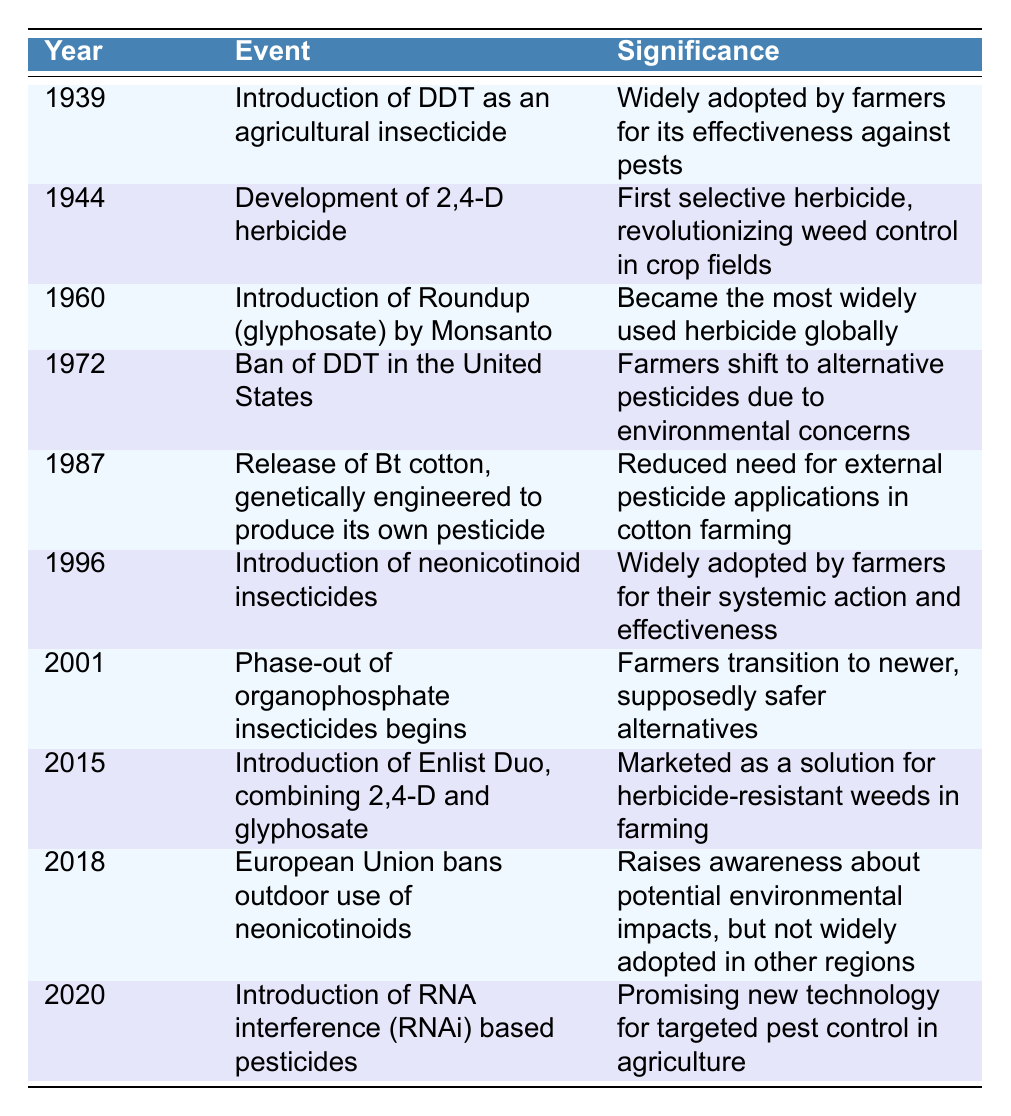What year was DDT introduced as an agricultural insecticide? The table clearly shows that DDT was introduced in the year 1939.
Answer: 1939 What was the significance of the development of 2,4-D herbicide in 1944? According to the table, 2,4-D was significant as it was the first selective herbicide, revolutionizing weed control in crop fields.
Answer: First selective herbicide, revolutionizing weed control in crop fields True or False: Roundup (glyphosate) was introduced before 1970. The table lists the introduction of Roundup in 1960, which is indeed before 1970.
Answer: True How many years passed between the introduction of DDT and the ban of DDT in the United States? The introduction of DDT was in 1939, and the ban occurred in 1972. The time difference is 1972 - 1939 = 33 years.
Answer: 33 years What event in 1987 reduced the need for external pesticide applications in cotton farming? The table indicates that in 1987, Bt cotton was released, which was genetically engineered to produce its own pesticide, thus reducing the need for external applications.
Answer: Release of Bt cotton, genetically engineered to produce its own pesticide How many significant pesticide events occurred in the 2000s (2001 - 2020)? From the table, we see that there are three significant events: the phase-out of organophosphate insecticides begins in 2001, the introduction of Enlist Duo in 2015, and the introduction of RNA interference (RNAi) based pesticides in 2020. Counting these reveals there are three events in total.
Answer: 3 events What was significant about the introduction of neonicotinoids in 1996? The table notes that neonicotinoids were widely adopted by farmers for their systemic action and effectiveness, marking their significance in pest control.
Answer: Widely adopted by farmers for their systemic action and effectiveness Was the European Union's ban on neonicotinoids in 2018 a significant moment in terms of environmental awareness? The table points out that the ban in the European Union raised awareness about potential environmental impacts, confirming its significance in this context.
Answer: Yes 